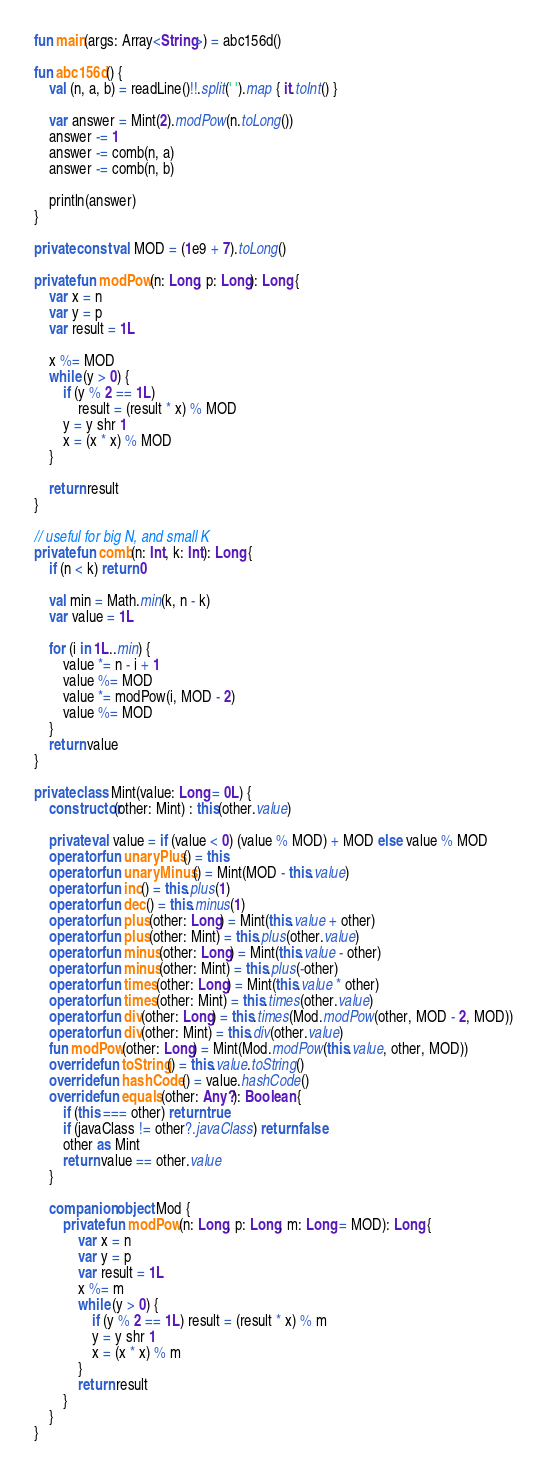Convert code to text. <code><loc_0><loc_0><loc_500><loc_500><_Kotlin_>fun main(args: Array<String>) = abc156d()

fun abc156d() {
    val (n, a, b) = readLine()!!.split(' ').map { it.toInt() }

    var answer = Mint(2).modPow(n.toLong())
    answer -= 1
    answer -= comb(n, a)
    answer -= comb(n, b)

    println(answer)
}

private const val MOD = (1e9 + 7).toLong()

private fun modPow(n: Long, p: Long): Long {
    var x = n
    var y = p
    var result = 1L

    x %= MOD
    while (y > 0) {
        if (y % 2 == 1L)
            result = (result * x) % MOD
        y = y shr 1
        x = (x * x) % MOD
    }

    return result
}

// useful for big N, and small K
private fun comb(n: Int, k: Int): Long {
    if (n < k) return 0

    val min = Math.min(k, n - k)
    var value = 1L

    for (i in 1L..min) {
        value *= n - i + 1
        value %= MOD
        value *= modPow(i, MOD - 2)
        value %= MOD
    }
    return value
}

private class Mint(value: Long = 0L) {
    constructor(other: Mint) : this(other.value)

    private val value = if (value < 0) (value % MOD) + MOD else value % MOD
    operator fun unaryPlus() = this
    operator fun unaryMinus() = Mint(MOD - this.value)
    operator fun inc() = this.plus(1)
    operator fun dec() = this.minus(1)
    operator fun plus(other: Long) = Mint(this.value + other)
    operator fun plus(other: Mint) = this.plus(other.value)
    operator fun minus(other: Long) = Mint(this.value - other)
    operator fun minus(other: Mint) = this.plus(-other)
    operator fun times(other: Long) = Mint(this.value * other)
    operator fun times(other: Mint) = this.times(other.value)
    operator fun div(other: Long) = this.times(Mod.modPow(other, MOD - 2, MOD))
    operator fun div(other: Mint) = this.div(other.value)
    fun modPow(other: Long) = Mint(Mod.modPow(this.value, other, MOD))
    override fun toString() = this.value.toString()
    override fun hashCode() = value.hashCode()
    override fun equals(other: Any?): Boolean {
        if (this === other) return true
        if (javaClass != other?.javaClass) return false
        other as Mint
        return value == other.value
    }

    companion object Mod {
        private fun modPow(n: Long, p: Long, m: Long = MOD): Long {
            var x = n
            var y = p
            var result = 1L
            x %= m
            while (y > 0) {
                if (y % 2 == 1L) result = (result * x) % m
                y = y shr 1
                x = (x * x) % m
            }
            return result
        }
    }
}
</code> 